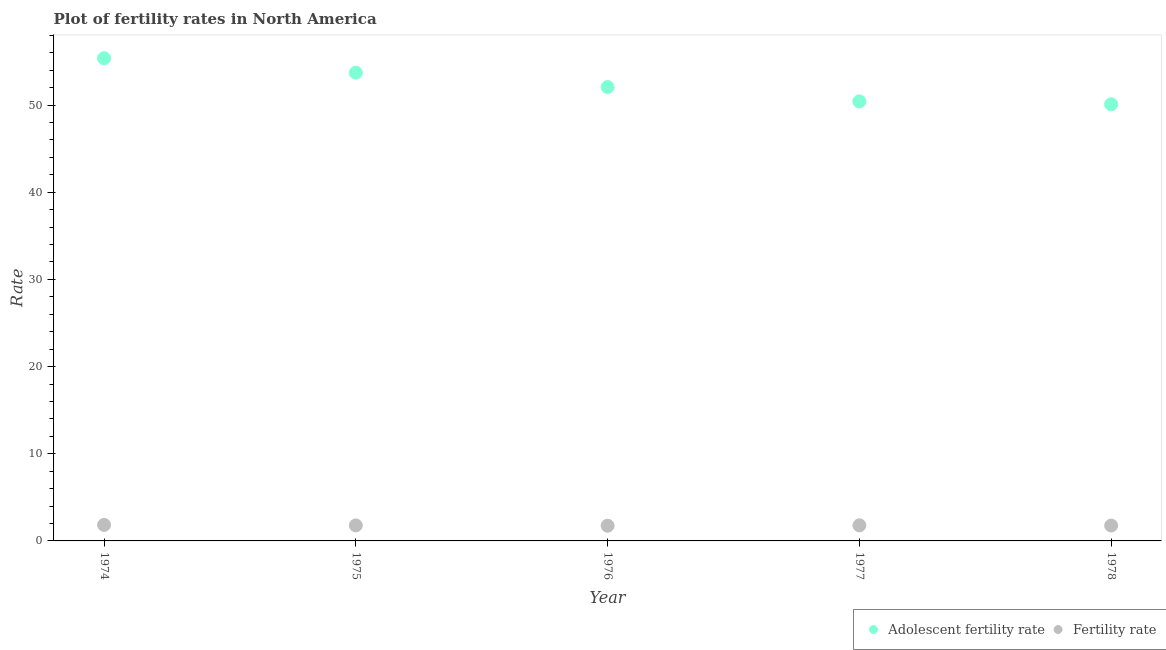How many different coloured dotlines are there?
Your answer should be very brief. 2. Is the number of dotlines equal to the number of legend labels?
Provide a short and direct response. Yes. What is the adolescent fertility rate in 1977?
Give a very brief answer. 50.43. Across all years, what is the maximum adolescent fertility rate?
Provide a short and direct response. 55.37. Across all years, what is the minimum adolescent fertility rate?
Your response must be concise. 50.09. In which year was the fertility rate maximum?
Give a very brief answer. 1974. In which year was the fertility rate minimum?
Provide a short and direct response. 1976. What is the total adolescent fertility rate in the graph?
Provide a short and direct response. 261.69. What is the difference between the fertility rate in 1974 and that in 1977?
Offer a very short reply. 0.05. What is the difference between the adolescent fertility rate in 1978 and the fertility rate in 1974?
Your response must be concise. 48.26. What is the average adolescent fertility rate per year?
Ensure brevity in your answer.  52.34. In the year 1976, what is the difference between the fertility rate and adolescent fertility rate?
Provide a short and direct response. -50.33. In how many years, is the fertility rate greater than 16?
Provide a short and direct response. 0. What is the ratio of the fertility rate in 1976 to that in 1978?
Your answer should be very brief. 0.99. Is the difference between the adolescent fertility rate in 1976 and 1978 greater than the difference between the fertility rate in 1976 and 1978?
Give a very brief answer. Yes. What is the difference between the highest and the second highest adolescent fertility rate?
Make the answer very short. 1.65. What is the difference between the highest and the lowest fertility rate?
Provide a short and direct response. 0.09. In how many years, is the adolescent fertility rate greater than the average adolescent fertility rate taken over all years?
Provide a succinct answer. 2. Is the sum of the fertility rate in 1976 and 1977 greater than the maximum adolescent fertility rate across all years?
Provide a succinct answer. No. Is the fertility rate strictly less than the adolescent fertility rate over the years?
Offer a very short reply. Yes. How many dotlines are there?
Keep it short and to the point. 2. What is the difference between two consecutive major ticks on the Y-axis?
Provide a short and direct response. 10. Does the graph contain grids?
Provide a succinct answer. No. How are the legend labels stacked?
Your answer should be compact. Horizontal. What is the title of the graph?
Provide a succinct answer. Plot of fertility rates in North America. Does "Researchers" appear as one of the legend labels in the graph?
Your answer should be very brief. No. What is the label or title of the X-axis?
Provide a succinct answer. Year. What is the label or title of the Y-axis?
Your answer should be compact. Rate. What is the Rate in Adolescent fertility rate in 1974?
Keep it short and to the point. 55.37. What is the Rate in Fertility rate in 1974?
Offer a terse response. 1.84. What is the Rate in Adolescent fertility rate in 1975?
Provide a succinct answer. 53.72. What is the Rate of Fertility rate in 1975?
Keep it short and to the point. 1.78. What is the Rate in Adolescent fertility rate in 1976?
Make the answer very short. 52.07. What is the Rate of Fertility rate in 1976?
Offer a very short reply. 1.74. What is the Rate of Adolescent fertility rate in 1977?
Make the answer very short. 50.43. What is the Rate of Fertility rate in 1977?
Ensure brevity in your answer.  1.79. What is the Rate in Adolescent fertility rate in 1978?
Make the answer very short. 50.09. What is the Rate of Fertility rate in 1978?
Your answer should be compact. 1.76. Across all years, what is the maximum Rate of Adolescent fertility rate?
Offer a terse response. 55.37. Across all years, what is the maximum Rate in Fertility rate?
Make the answer very short. 1.84. Across all years, what is the minimum Rate of Adolescent fertility rate?
Provide a short and direct response. 50.09. Across all years, what is the minimum Rate in Fertility rate?
Keep it short and to the point. 1.74. What is the total Rate in Adolescent fertility rate in the graph?
Ensure brevity in your answer.  261.69. What is the total Rate of Fertility rate in the graph?
Your response must be concise. 8.91. What is the difference between the Rate in Adolescent fertility rate in 1974 and that in 1975?
Ensure brevity in your answer.  1.65. What is the difference between the Rate of Fertility rate in 1974 and that in 1975?
Keep it short and to the point. 0.06. What is the difference between the Rate of Adolescent fertility rate in 1974 and that in 1976?
Make the answer very short. 3.3. What is the difference between the Rate in Fertility rate in 1974 and that in 1976?
Ensure brevity in your answer.  0.09. What is the difference between the Rate in Adolescent fertility rate in 1974 and that in 1977?
Your answer should be compact. 4.95. What is the difference between the Rate of Fertility rate in 1974 and that in 1977?
Keep it short and to the point. 0.05. What is the difference between the Rate of Adolescent fertility rate in 1974 and that in 1978?
Keep it short and to the point. 5.28. What is the difference between the Rate of Fertility rate in 1974 and that in 1978?
Your answer should be compact. 0.07. What is the difference between the Rate of Adolescent fertility rate in 1975 and that in 1976?
Offer a terse response. 1.65. What is the difference between the Rate of Fertility rate in 1975 and that in 1976?
Keep it short and to the point. 0.04. What is the difference between the Rate in Adolescent fertility rate in 1975 and that in 1977?
Give a very brief answer. 3.3. What is the difference between the Rate of Fertility rate in 1975 and that in 1977?
Provide a short and direct response. -0.01. What is the difference between the Rate of Adolescent fertility rate in 1975 and that in 1978?
Make the answer very short. 3.63. What is the difference between the Rate of Fertility rate in 1975 and that in 1978?
Your response must be concise. 0.02. What is the difference between the Rate in Adolescent fertility rate in 1976 and that in 1977?
Give a very brief answer. 1.65. What is the difference between the Rate in Fertility rate in 1976 and that in 1977?
Your response must be concise. -0.05. What is the difference between the Rate of Adolescent fertility rate in 1976 and that in 1978?
Ensure brevity in your answer.  1.98. What is the difference between the Rate in Fertility rate in 1976 and that in 1978?
Offer a very short reply. -0.02. What is the difference between the Rate in Adolescent fertility rate in 1977 and that in 1978?
Your answer should be very brief. 0.33. What is the difference between the Rate of Fertility rate in 1977 and that in 1978?
Make the answer very short. 0.03. What is the difference between the Rate of Adolescent fertility rate in 1974 and the Rate of Fertility rate in 1975?
Provide a succinct answer. 53.59. What is the difference between the Rate in Adolescent fertility rate in 1974 and the Rate in Fertility rate in 1976?
Offer a very short reply. 53.63. What is the difference between the Rate of Adolescent fertility rate in 1974 and the Rate of Fertility rate in 1977?
Make the answer very short. 53.58. What is the difference between the Rate in Adolescent fertility rate in 1974 and the Rate in Fertility rate in 1978?
Give a very brief answer. 53.61. What is the difference between the Rate of Adolescent fertility rate in 1975 and the Rate of Fertility rate in 1976?
Your answer should be very brief. 51.98. What is the difference between the Rate in Adolescent fertility rate in 1975 and the Rate in Fertility rate in 1977?
Offer a very short reply. 51.93. What is the difference between the Rate of Adolescent fertility rate in 1975 and the Rate of Fertility rate in 1978?
Make the answer very short. 51.96. What is the difference between the Rate in Adolescent fertility rate in 1976 and the Rate in Fertility rate in 1977?
Provide a succinct answer. 50.29. What is the difference between the Rate of Adolescent fertility rate in 1976 and the Rate of Fertility rate in 1978?
Provide a succinct answer. 50.31. What is the difference between the Rate in Adolescent fertility rate in 1977 and the Rate in Fertility rate in 1978?
Offer a very short reply. 48.66. What is the average Rate in Adolescent fertility rate per year?
Keep it short and to the point. 52.34. What is the average Rate in Fertility rate per year?
Your answer should be very brief. 1.78. In the year 1974, what is the difference between the Rate of Adolescent fertility rate and Rate of Fertility rate?
Your response must be concise. 53.54. In the year 1975, what is the difference between the Rate of Adolescent fertility rate and Rate of Fertility rate?
Your answer should be very brief. 51.94. In the year 1976, what is the difference between the Rate of Adolescent fertility rate and Rate of Fertility rate?
Provide a short and direct response. 50.33. In the year 1977, what is the difference between the Rate in Adolescent fertility rate and Rate in Fertility rate?
Provide a short and direct response. 48.64. In the year 1978, what is the difference between the Rate in Adolescent fertility rate and Rate in Fertility rate?
Give a very brief answer. 48.33. What is the ratio of the Rate of Adolescent fertility rate in 1974 to that in 1975?
Provide a short and direct response. 1.03. What is the ratio of the Rate of Fertility rate in 1974 to that in 1975?
Your response must be concise. 1.03. What is the ratio of the Rate in Adolescent fertility rate in 1974 to that in 1976?
Provide a succinct answer. 1.06. What is the ratio of the Rate of Fertility rate in 1974 to that in 1976?
Your answer should be very brief. 1.05. What is the ratio of the Rate in Adolescent fertility rate in 1974 to that in 1977?
Ensure brevity in your answer.  1.1. What is the ratio of the Rate in Fertility rate in 1974 to that in 1977?
Your answer should be compact. 1.03. What is the ratio of the Rate of Adolescent fertility rate in 1974 to that in 1978?
Your answer should be very brief. 1.11. What is the ratio of the Rate in Fertility rate in 1974 to that in 1978?
Provide a succinct answer. 1.04. What is the ratio of the Rate in Adolescent fertility rate in 1975 to that in 1976?
Give a very brief answer. 1.03. What is the ratio of the Rate in Fertility rate in 1975 to that in 1976?
Provide a short and direct response. 1.02. What is the ratio of the Rate in Adolescent fertility rate in 1975 to that in 1977?
Make the answer very short. 1.07. What is the ratio of the Rate in Fertility rate in 1975 to that in 1977?
Provide a short and direct response. 0.99. What is the ratio of the Rate in Adolescent fertility rate in 1975 to that in 1978?
Keep it short and to the point. 1.07. What is the ratio of the Rate in Fertility rate in 1975 to that in 1978?
Ensure brevity in your answer.  1.01. What is the ratio of the Rate of Adolescent fertility rate in 1976 to that in 1977?
Make the answer very short. 1.03. What is the ratio of the Rate of Fertility rate in 1976 to that in 1977?
Provide a short and direct response. 0.97. What is the ratio of the Rate in Adolescent fertility rate in 1976 to that in 1978?
Your answer should be very brief. 1.04. What is the ratio of the Rate of Adolescent fertility rate in 1977 to that in 1978?
Your response must be concise. 1.01. What is the ratio of the Rate of Fertility rate in 1977 to that in 1978?
Make the answer very short. 1.02. What is the difference between the highest and the second highest Rate in Adolescent fertility rate?
Make the answer very short. 1.65. What is the difference between the highest and the second highest Rate in Fertility rate?
Provide a succinct answer. 0.05. What is the difference between the highest and the lowest Rate of Adolescent fertility rate?
Make the answer very short. 5.28. What is the difference between the highest and the lowest Rate of Fertility rate?
Your answer should be very brief. 0.09. 